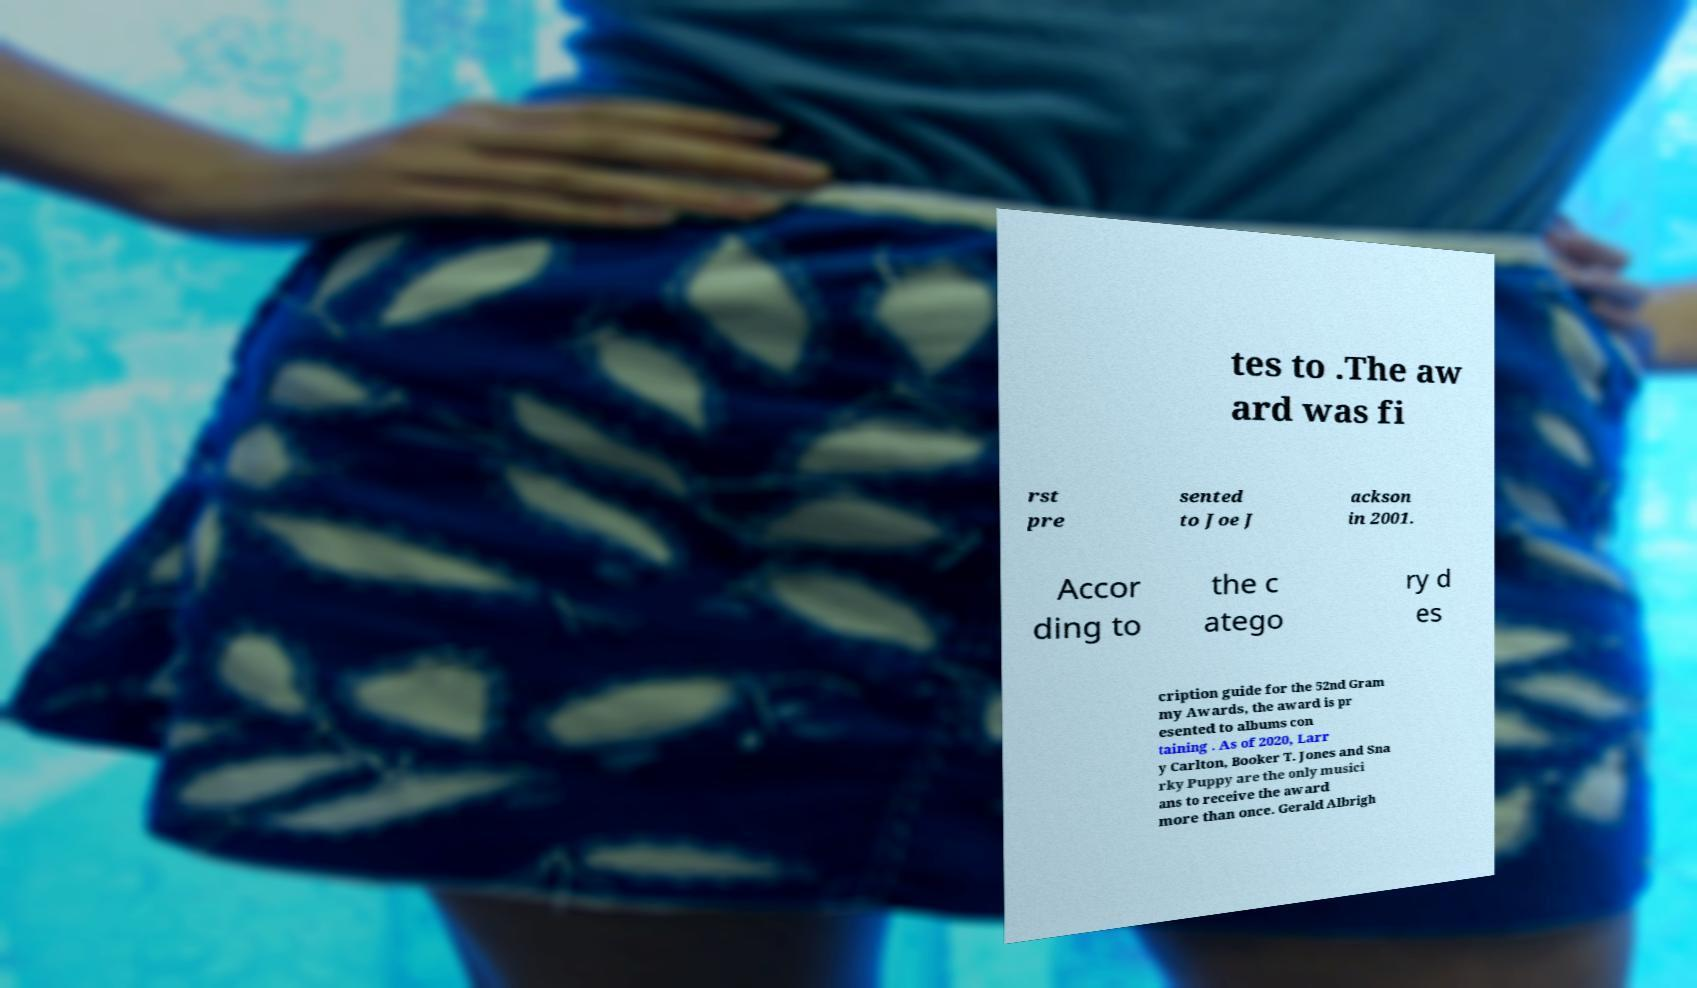Could you extract and type out the text from this image? tes to .The aw ard was fi rst pre sented to Joe J ackson in 2001. Accor ding to the c atego ry d es cription guide for the 52nd Gram my Awards, the award is pr esented to albums con taining . As of 2020, Larr y Carlton, Booker T. Jones and Sna rky Puppy are the only musici ans to receive the award more than once. Gerald Albrigh 